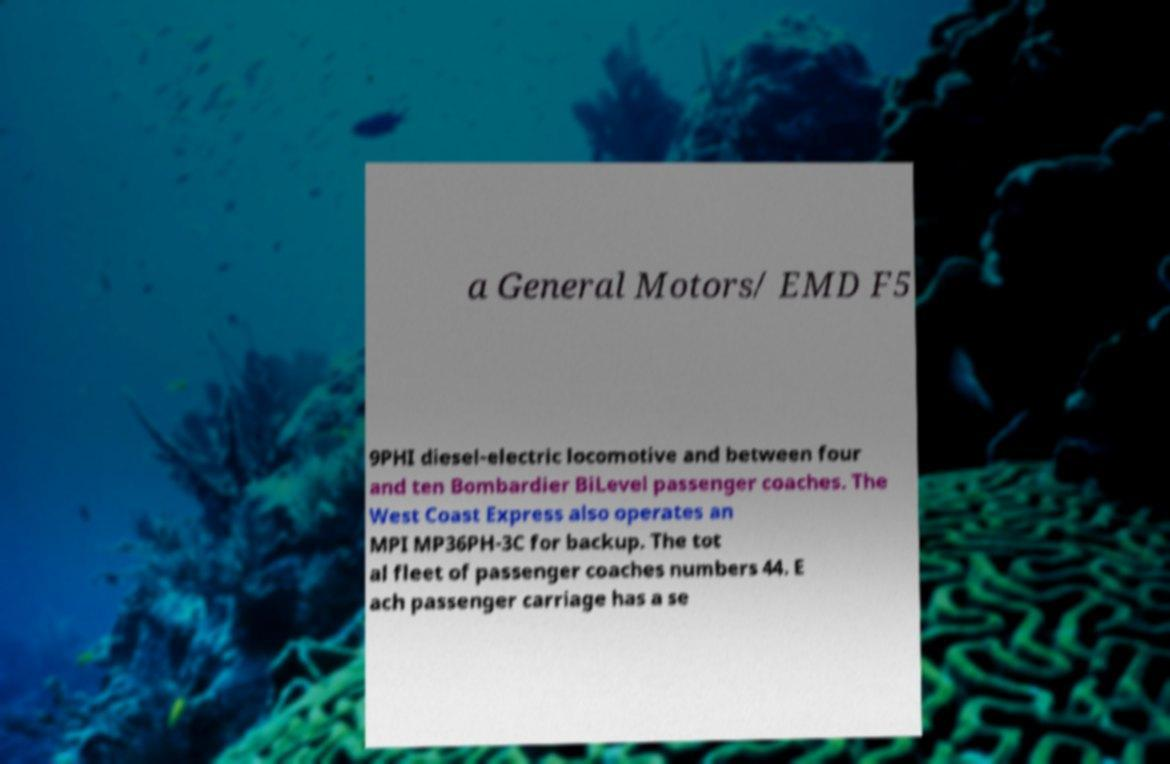Could you assist in decoding the text presented in this image and type it out clearly? a General Motors/ EMD F5 9PHI diesel-electric locomotive and between four and ten Bombardier BiLevel passenger coaches. The West Coast Express also operates an MPI MP36PH-3C for backup. The tot al fleet of passenger coaches numbers 44. E ach passenger carriage has a se 